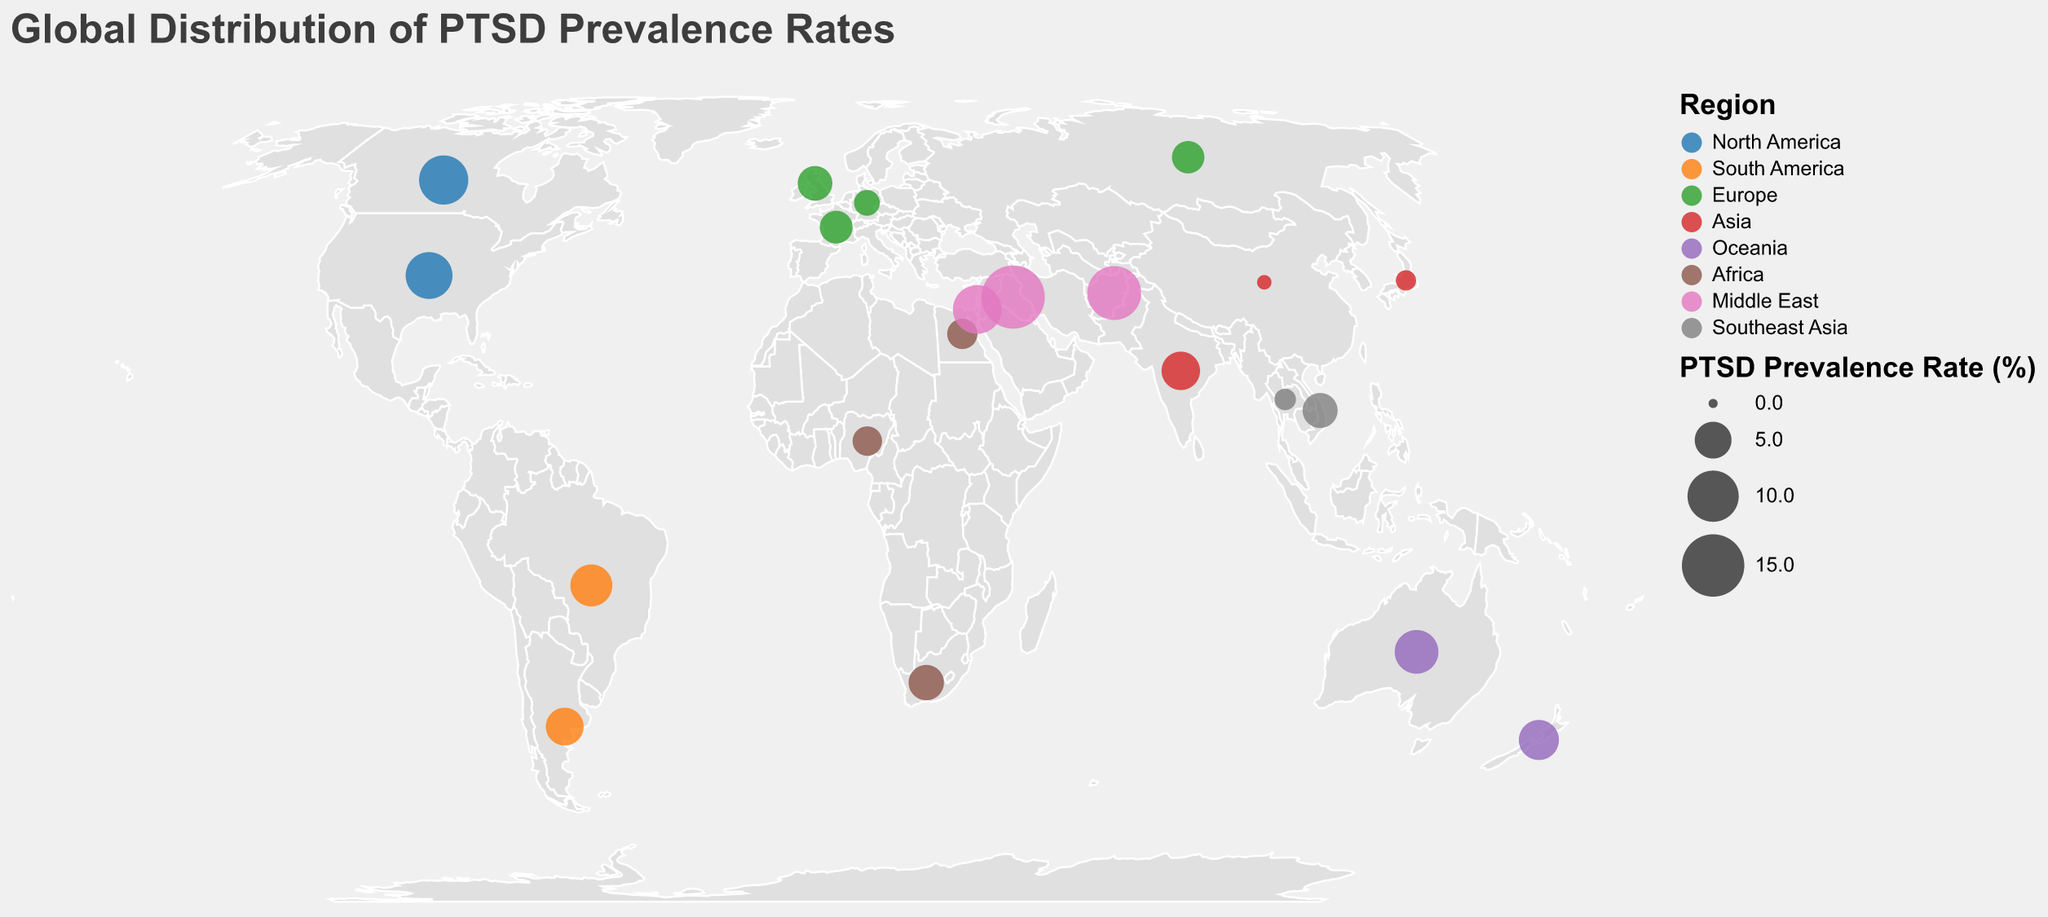what is the PTSD prevalence rate in Iraq? Iraq has a marked data point on the map. Hovering over this data point or researching the legend will reveal the prevalence rate. It shows that Iraq has a PTSD prevalence rate of 15.4%.
Answer: 15.4% Which region has the highest average PTSD prevalence rate? Calculate the average PTSD prevalence rate for each region: First list all countries in each region and sum their PTSD rates. Then divide by the number of countries in that region.
For North America:(8.3+9.2)/2 = 8.75,
For South America: (6.6 + 5.3) / 2 = 5.95,
For Europe: (4.4 + 2.3 + 3.9 + 3.8) / 4 = 3.6,
For Asia (0.5 + 1.3 + 5.5) / 3 = 2.43,
For Oceania: (7.2 + 6.0) / 2 = 6.6,
For Africa: (4.6 + 3.1 + 3.3) / 3 = 3.67,
For Middle East: (9.0 + 15.4 + 11.1) / 3 = 11.83,
For Southeast Asia: (1.5 + 4.5) / 2 = 3.0.
The Middle East has the highest average PTSD prevalence rate.
Answer: Middle East Compare PTSD prevalence rates between the United States and Canada. Looking at the data points for North America, the PTSD prevalence rate for the United States is 8.3% and for Canada is 9.2%. Canada has a slightly higher rate.
Answer: 9.2% vs 8.3% Which country in the Middle East has the lowest PTSD prevalence rate? In the Middle East, the three countries are Israel, Iraq, and Afghanistan. Their PTSD prevalence rates are 9.0%, 15.4%, and 11.1% respectively. Therefore, Israel has the lowest PTSD prevalence rate.
Answer: Israel What is the difference in PTSD prevalence rate between Germany and the United Kingdom? Referring to the data points in Europe, Germany has a PTSD prevalence rate of 2.3% while the United Kingdom has a rate of 4.4%. The difference is 4.4% - 2.3% = 2.1%.
Answer: 2.1% What is the range of PTSD prevalence rates in Africa? In Africa, the PTSD prevalence rates are for South Africa (4.6%), Nigeria (3.1%), and Egypt (3.3%). The highest rate is 4.6% and the lowest is 3.1%. So the range is 4.6% - 3.1% = 1.5%.
Answer: 1.5% Identify the region with the most number of countries on the plot. How many countries does it have? By counting the data points, Europe has the following countries: United Kingdom, Germany, France, and Russia, making it a total of 4 countries, which is the maximum compared to other regions.
Answer: Europe, 4 countries Highlight the country with the lowest PTSD prevalence rate and its corresponding region. Reviewing the data points, China's PTSD prevalence rate is the lowest at 0.5%. This country is in the Asia region.
Answer: China, Asia 